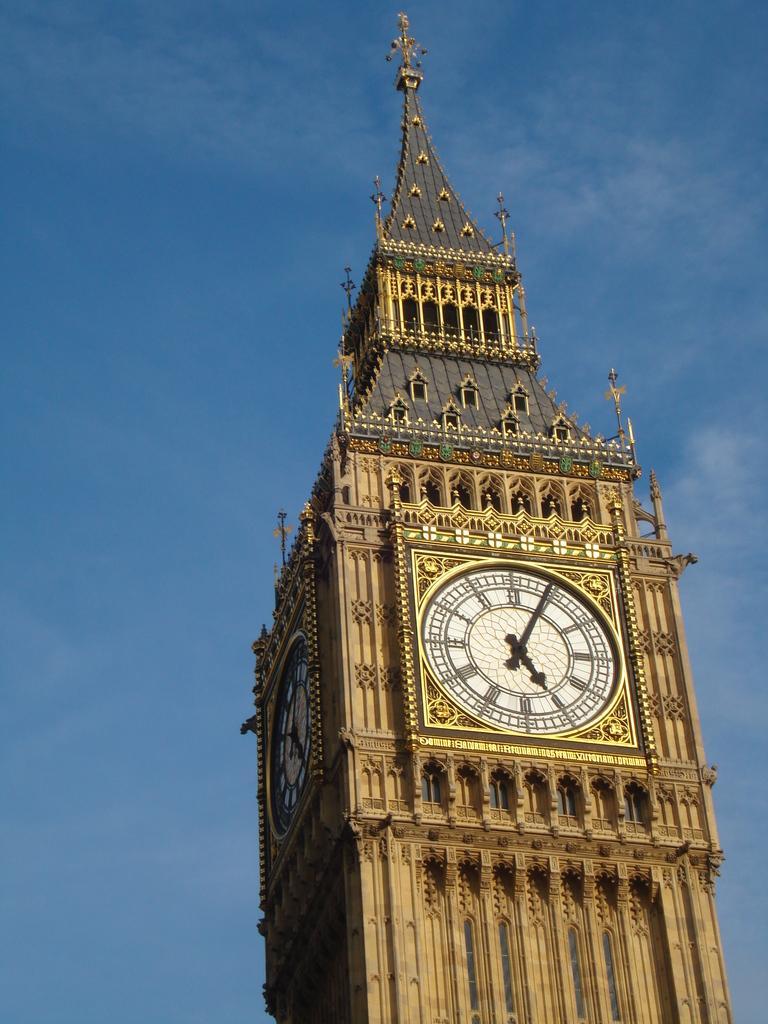How would you summarize this image in a sentence or two? In this picture, we see the clock tower. In the background, we see the sky, which is blue in color. 